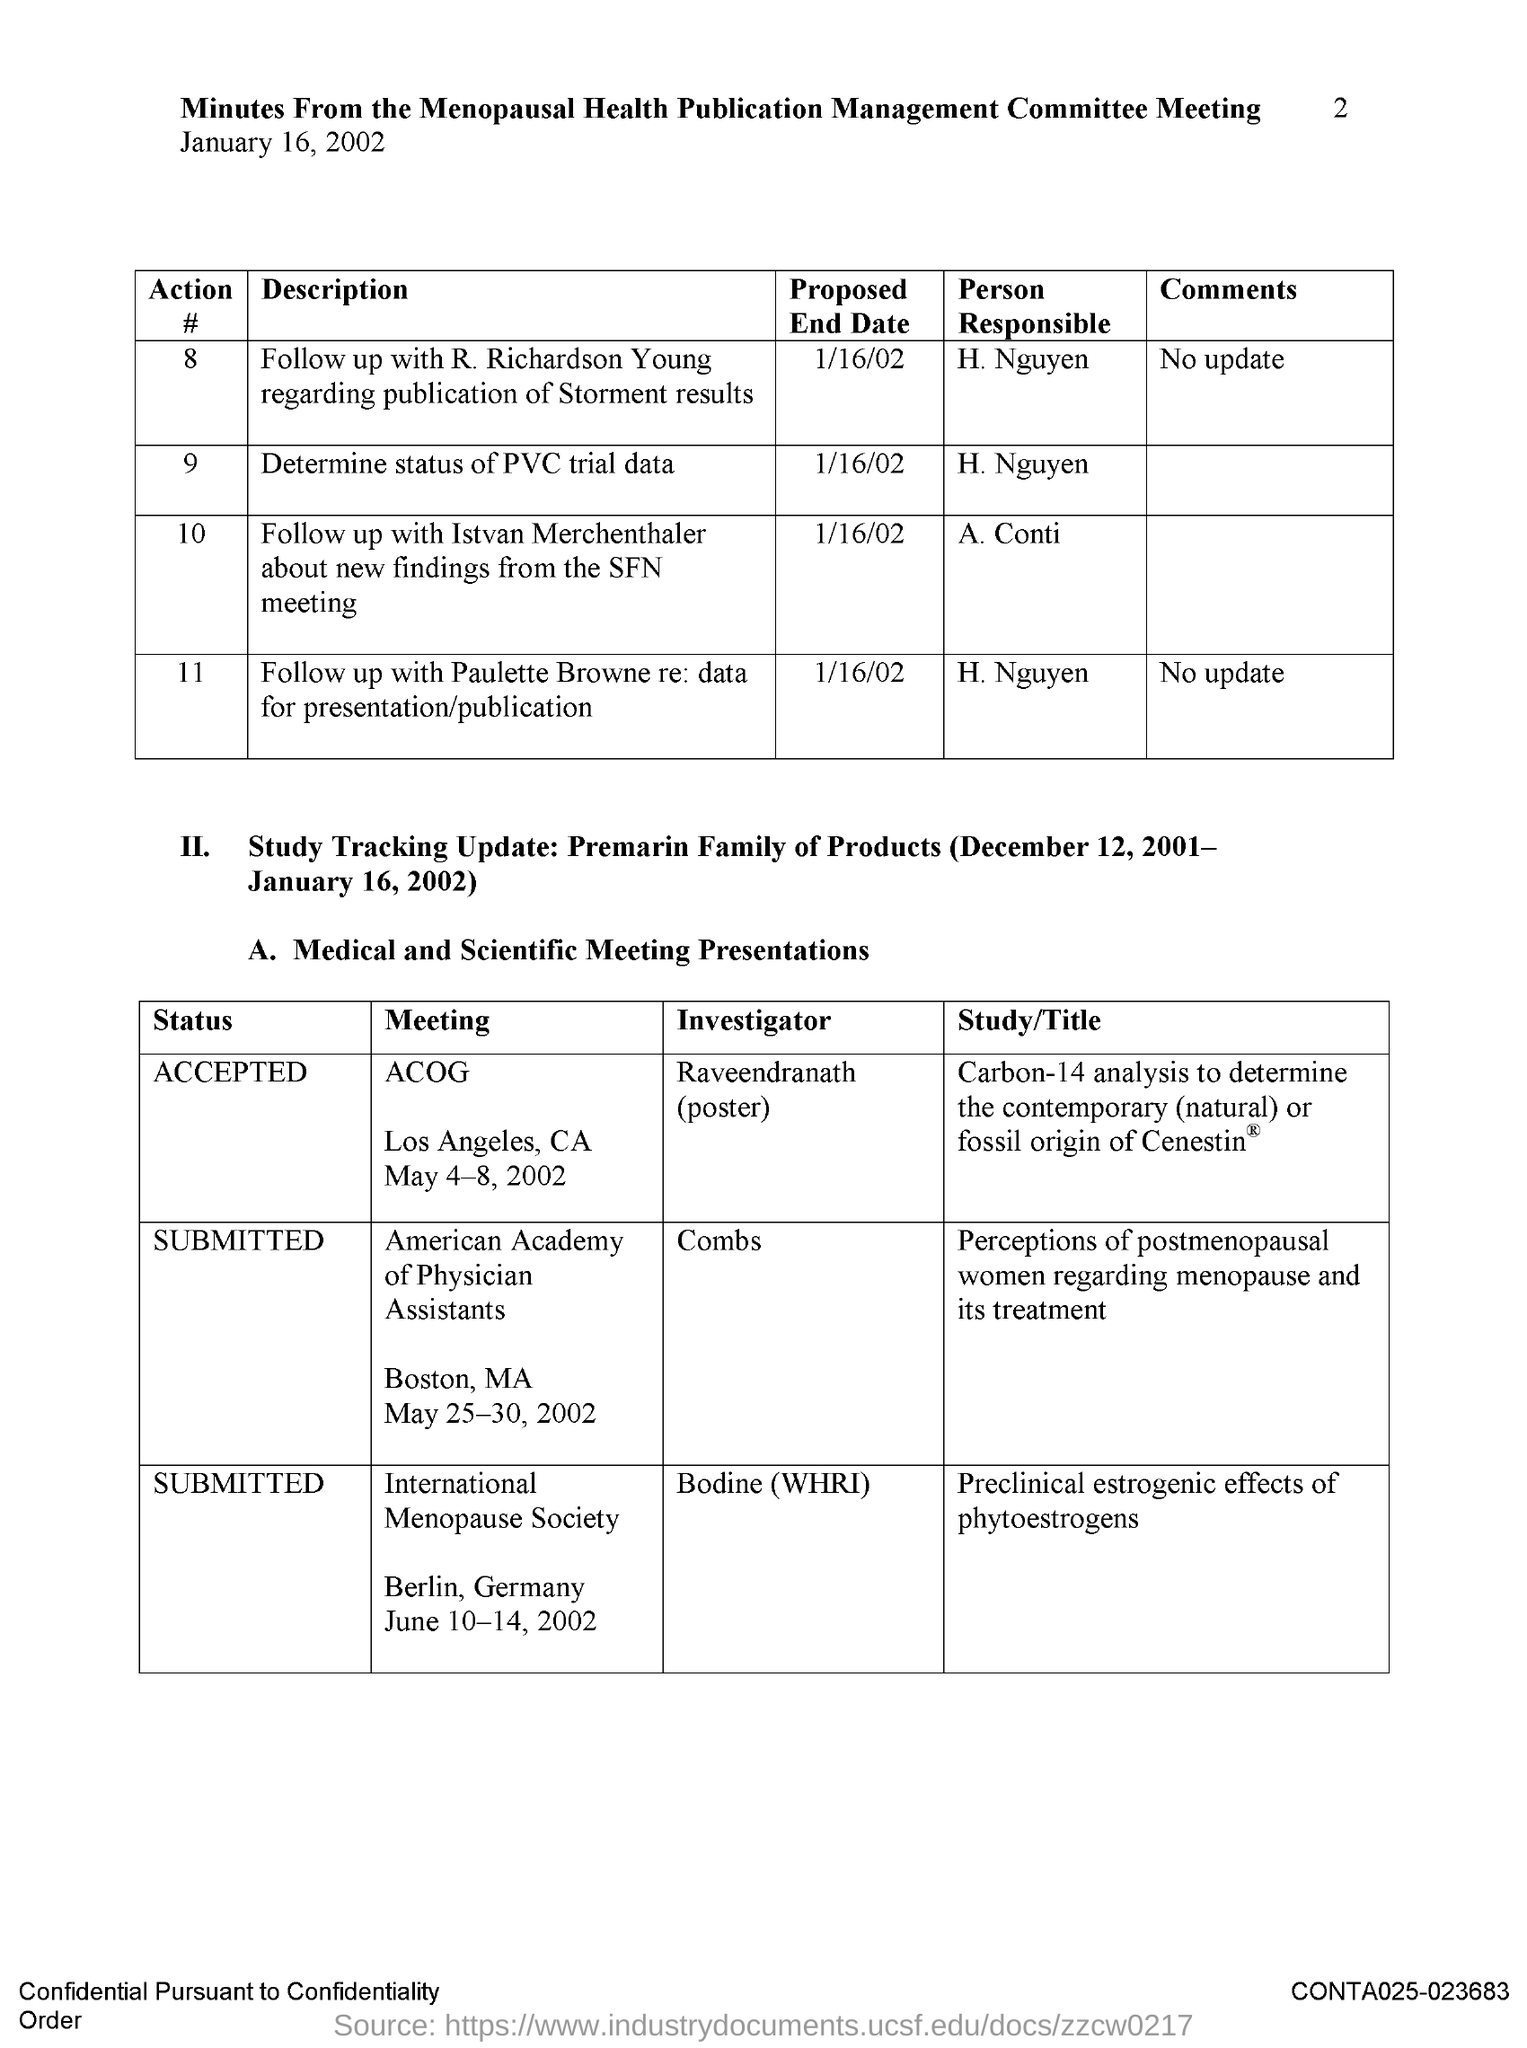When is the Menopausal Health Publication Management Meeting held?
Offer a terse response. January 16, 2002. Who is the person responsible to determine the status of PVC trial data?
Make the answer very short. H. Nguyen. What is the proposed end date to follow up wit R. Richardson Young regarding publication of storment results?
Ensure brevity in your answer.  1/16/02. Who is the person responsible to follow up wit R. Richardson Young regarding publication of storment results?
Make the answer very short. H. Nguyen. What is the proposed end date to determine the status of PVC trial data?
Offer a very short reply. 1/16/02. 